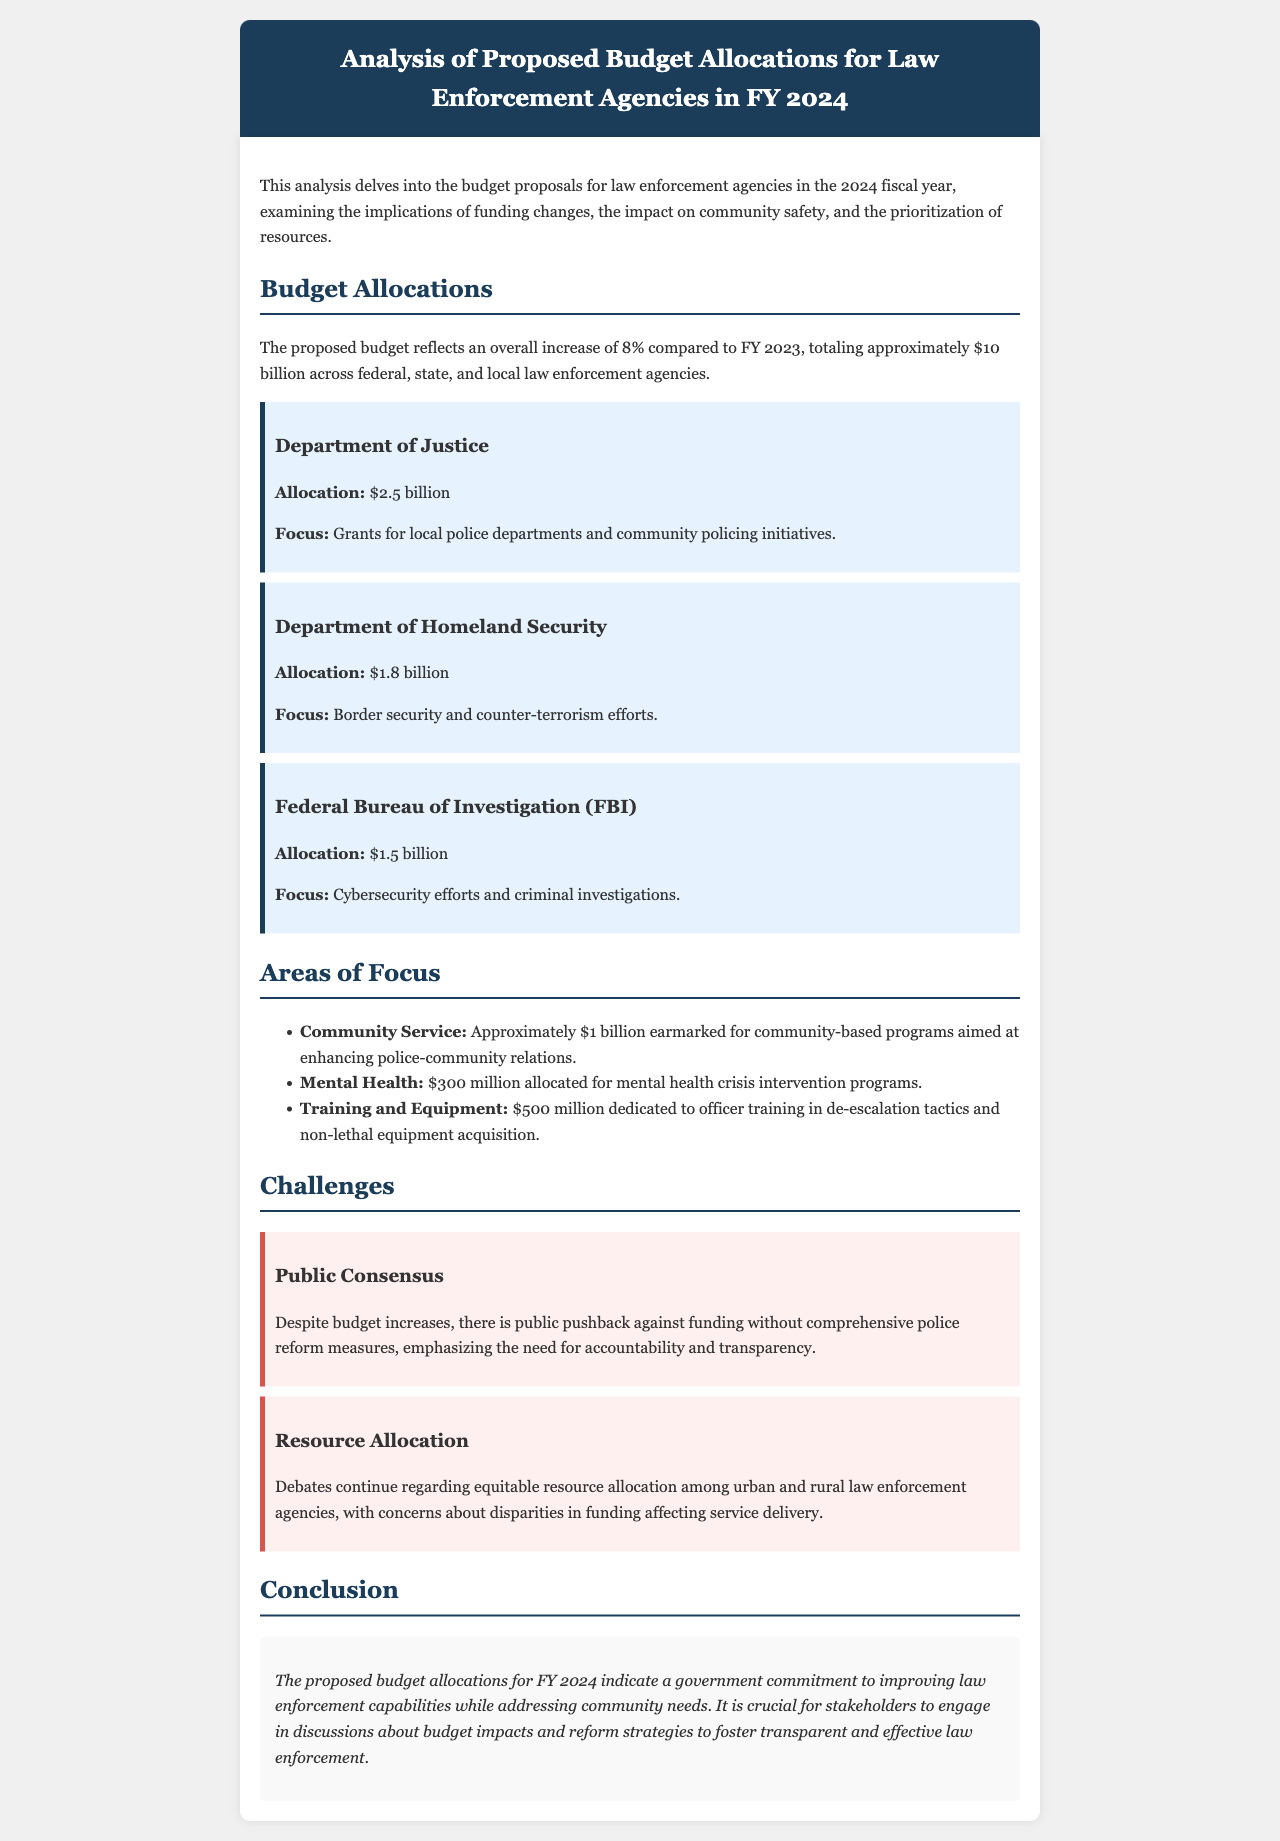What is the overall increase in the proposed budget compared to FY 2023? The document states that the proposed budget reflects an overall increase of 8% compared to FY 2023.
Answer: 8% What is the total proposed budget amount for law enforcement in FY 2024? The total proposed budget for law enforcement agencies is approximately $10 billion across federal, state, and local levels.
Answer: $10 billion How much is allocated to the Department of Justice? The document specifies that the allocation for the Department of Justice is $2.5 billion.
Answer: $2.5 billion What focus area receives $300 million in the proposed budget? The document indicates that $300 million is allocated for mental health crisis intervention programs.
Answer: Mental health crisis intervention programs What challenge is associated with public opinion regarding the budget? The document mentions public pushback against funding without comprehensive police reform measures as a challenge.
Answer: Public pushback Which department has the highest budget allocation? The document shows that the Department of Justice has the highest allocation of $2.5 billion.
Answer: Department of Justice What community service funding is earmarked in the budget? Approximately $1 billion is earmarked for community-based programs aimed at enhancing police-community relations.
Answer: $1 billion What is one major concern mentioned regarding resource allocation? The document discusses concerns about disparities in funding affecting service delivery among urban and rural law enforcement agencies.
Answer: Disparities in funding What is the document’s conclusion regarding the proposed budget allocations? The conclusion states that the proposed budget allocations indicate a government commitment to improving law enforcement capabilities while addressing community needs.
Answer: Government commitment to improving law enforcement capabilities 